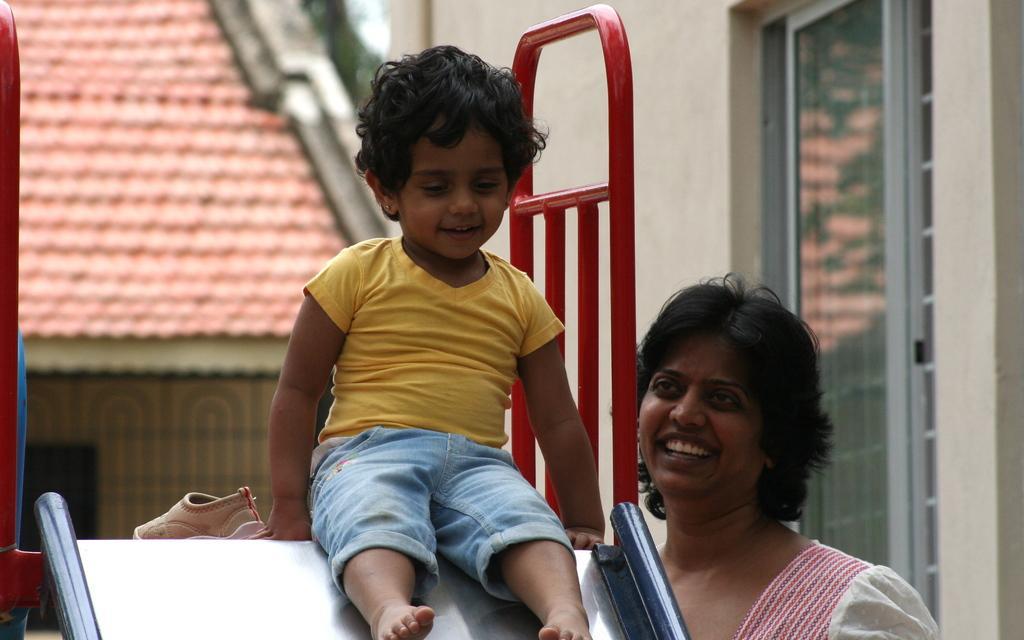Please provide a concise description of this image. As we can see in the image there are buildings, red color roof and two people in the front. 